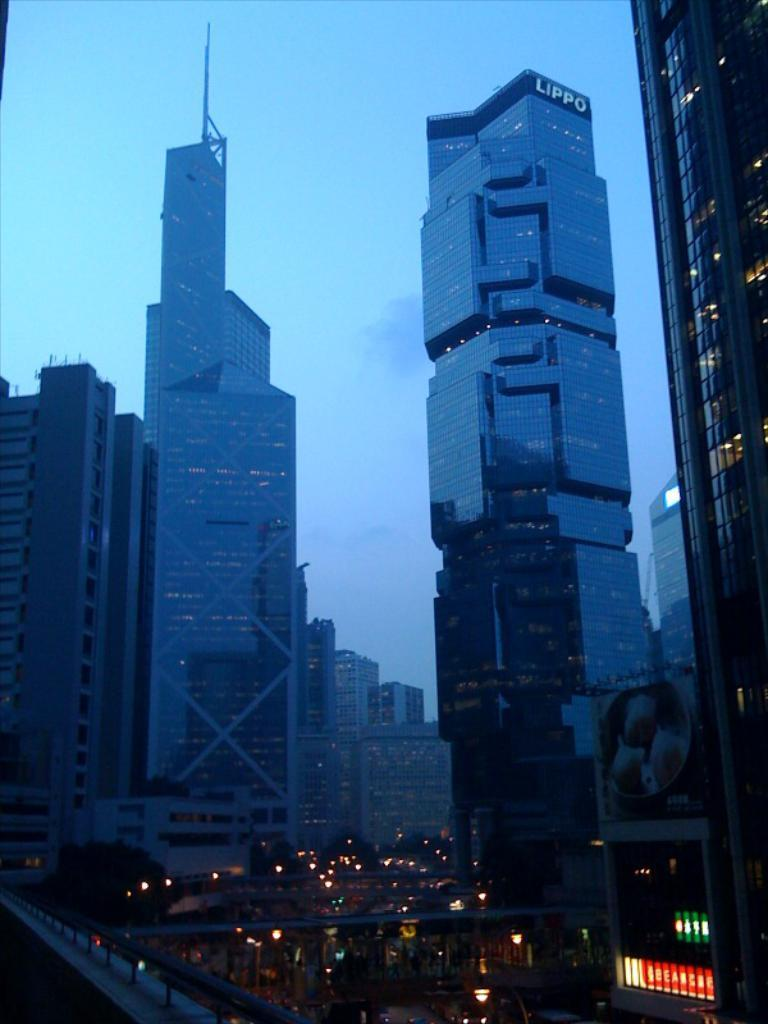What type of structures can be seen in the image? There are buildings in the image. What is located at the bottom of the image? There are lights and boards at the bottom of the image. What feature connects the two sides of the image? There is a bridge in the image. Reasoning: Let' Let's think step by step in order to produce the conversation. We start by identifying the main structures in the image, which are the buildings. Then, we describe the additional elements at the bottom of the image, including the lights and boards. Finally, we focus on the bridge as a key feature that connects the two sides of the image. Absurd Question/Answer: What is the income of the bean in the image? There is no bean present in the image, and therefore no income can be associated with it. 